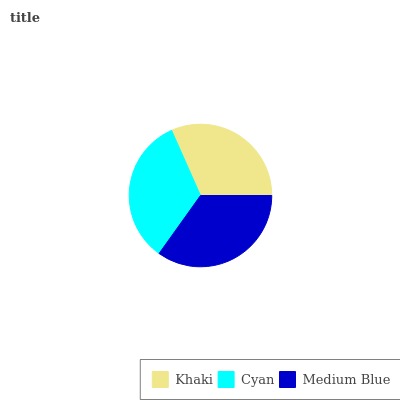Is Khaki the minimum?
Answer yes or no. Yes. Is Medium Blue the maximum?
Answer yes or no. Yes. Is Cyan the minimum?
Answer yes or no. No. Is Cyan the maximum?
Answer yes or no. No. Is Cyan greater than Khaki?
Answer yes or no. Yes. Is Khaki less than Cyan?
Answer yes or no. Yes. Is Khaki greater than Cyan?
Answer yes or no. No. Is Cyan less than Khaki?
Answer yes or no. No. Is Cyan the high median?
Answer yes or no. Yes. Is Cyan the low median?
Answer yes or no. Yes. Is Medium Blue the high median?
Answer yes or no. No. Is Khaki the low median?
Answer yes or no. No. 